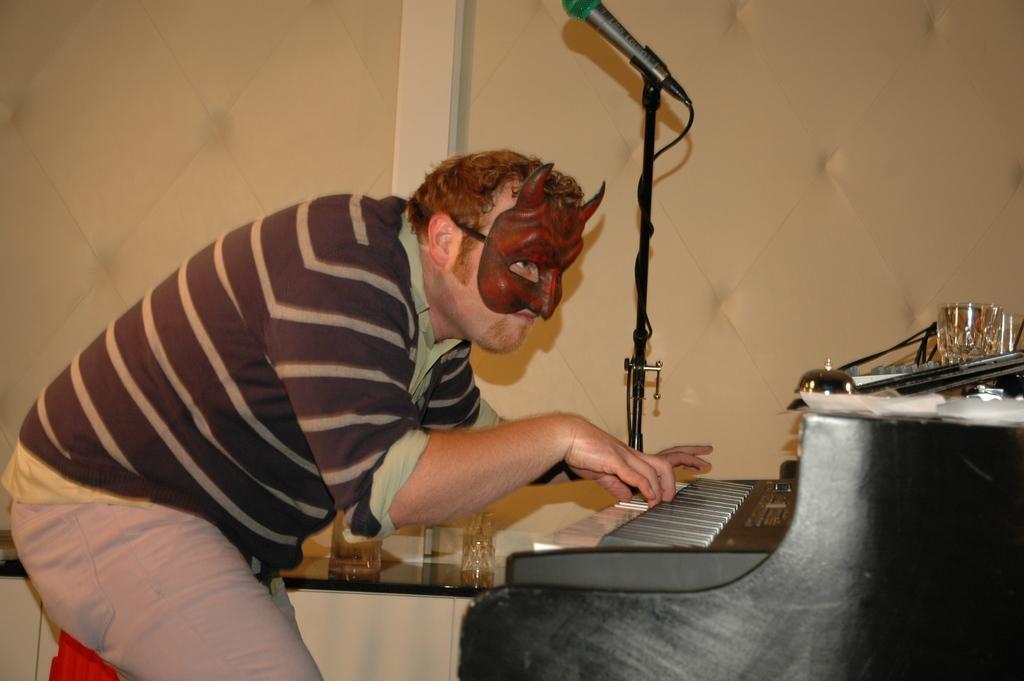Could you give a brief overview of what you see in this image? In this picture I can see a man who is wearing a mask and his playing the piano, and is standing and there is a microphone beside him and there is a wall in the backdrop 